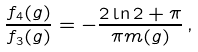<formula> <loc_0><loc_0><loc_500><loc_500>\frac { f _ { 4 } ( g ) } { f _ { 3 } ( g ) } = - \frac { 2 \ln 2 + \pi } { \pi m ( g ) } \, ,</formula> 